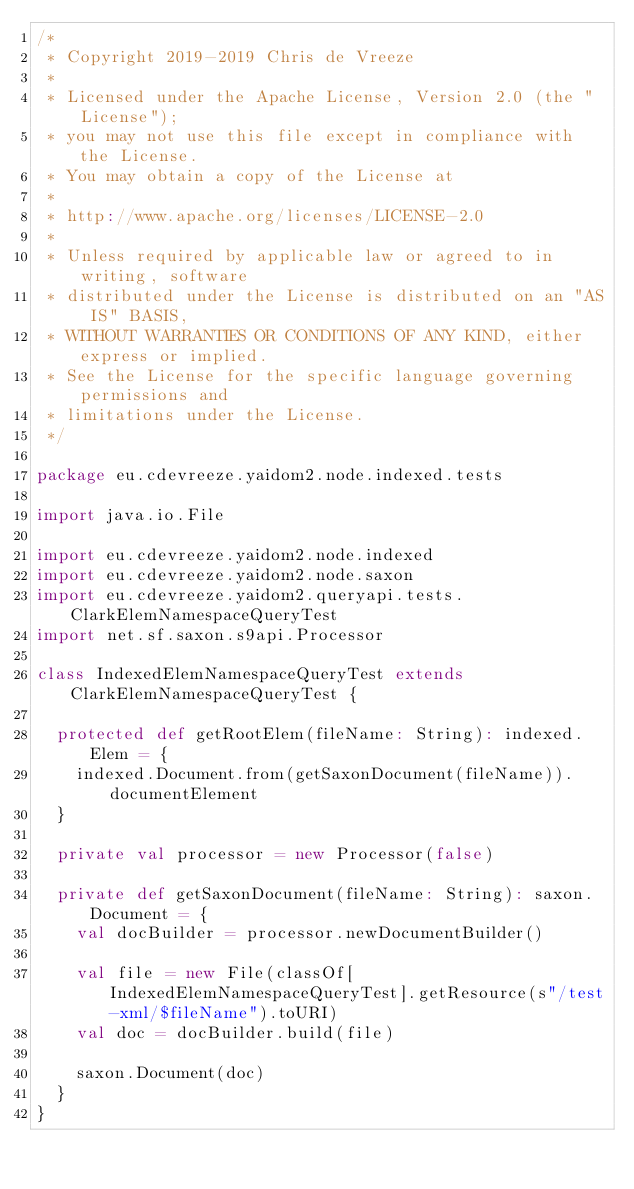<code> <loc_0><loc_0><loc_500><loc_500><_Scala_>/*
 * Copyright 2019-2019 Chris de Vreeze
 *
 * Licensed under the Apache License, Version 2.0 (the "License");
 * you may not use this file except in compliance with the License.
 * You may obtain a copy of the License at
 *
 * http://www.apache.org/licenses/LICENSE-2.0
 *
 * Unless required by applicable law or agreed to in writing, software
 * distributed under the License is distributed on an "AS IS" BASIS,
 * WITHOUT WARRANTIES OR CONDITIONS OF ANY KIND, either express or implied.
 * See the License for the specific language governing permissions and
 * limitations under the License.
 */

package eu.cdevreeze.yaidom2.node.indexed.tests

import java.io.File

import eu.cdevreeze.yaidom2.node.indexed
import eu.cdevreeze.yaidom2.node.saxon
import eu.cdevreeze.yaidom2.queryapi.tests.ClarkElemNamespaceQueryTest
import net.sf.saxon.s9api.Processor

class IndexedElemNamespaceQueryTest extends ClarkElemNamespaceQueryTest {

  protected def getRootElem(fileName: String): indexed.Elem = {
    indexed.Document.from(getSaxonDocument(fileName)).documentElement
  }

  private val processor = new Processor(false)

  private def getSaxonDocument(fileName: String): saxon.Document = {
    val docBuilder = processor.newDocumentBuilder()

    val file = new File(classOf[IndexedElemNamespaceQueryTest].getResource(s"/test-xml/$fileName").toURI)
    val doc = docBuilder.build(file)

    saxon.Document(doc)
  }
}
</code> 